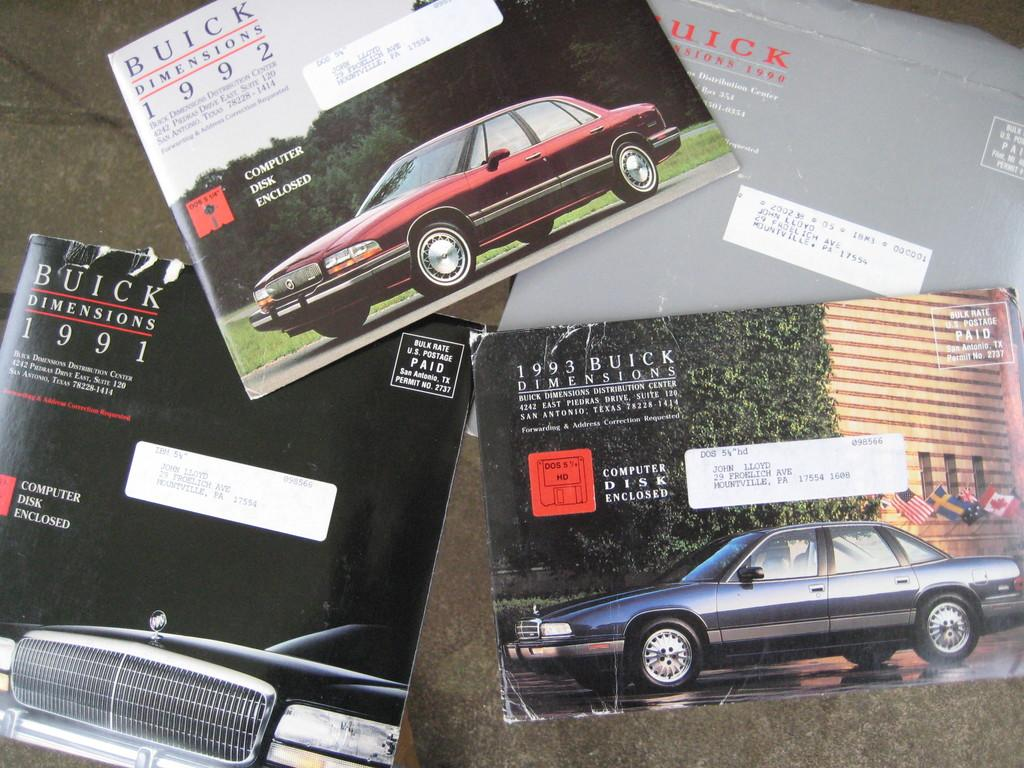What objects are visible in the image? There are books in the image. Where are the books located? The books are placed on a table. Can you describe the position of the table in the image? The table is in the center of the image. What type of ship can be seen sailing in the background of the image? There is no ship present in the image; it only features books placed on a table. How many feet are visible in the image? There are no feet visible in the image. 